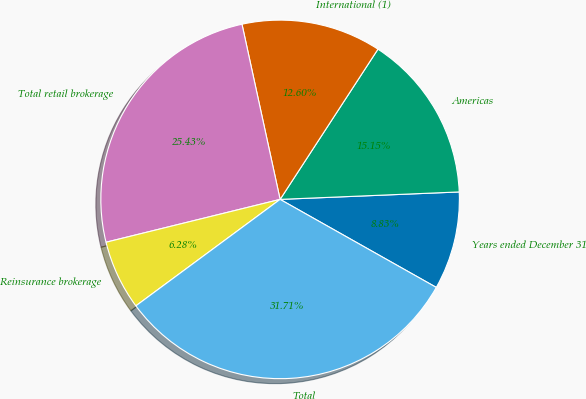<chart> <loc_0><loc_0><loc_500><loc_500><pie_chart><fcel>Years ended December 31<fcel>Americas<fcel>International (1)<fcel>Total retail brokerage<fcel>Reinsurance brokerage<fcel>Total<nl><fcel>8.83%<fcel>15.15%<fcel>12.6%<fcel>25.43%<fcel>6.28%<fcel>31.71%<nl></chart> 